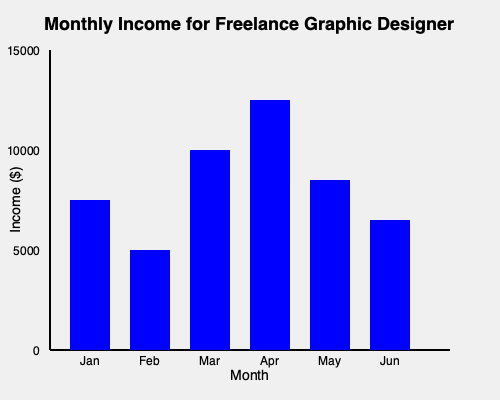Based on the bar graph showing your monthly income for the first half of the year, estimate your quarterly tax payment for Q2 (April to June) if you need to pay 25% of your income in taxes. Round your answer to the nearest hundred dollars. To estimate the quarterly tax payment for Q2, we need to follow these steps:

1. Identify the income for April, May, and June from the graph:
   April: $12,500 (5 units * $2,500 per unit)
   May: $8,500 (3.4 units * $2,500 per unit)
   June: $6,500 (2.6 units * $2,500 per unit)

2. Calculate the total income for Q2:
   $Q2_{income} = 12,500 + 8,500 + 6,500 = $27,500$

3. Calculate 25% of the Q2 income for tax payment:
   $Tax_{payment} = 27,500 \times 0.25 = $6,875$

4. Round the tax payment to the nearest hundred dollars:
   $Rounded_{tax} = $6,900$

Therefore, the estimated quarterly tax payment for Q2 is $6,900.
Answer: $6,900 